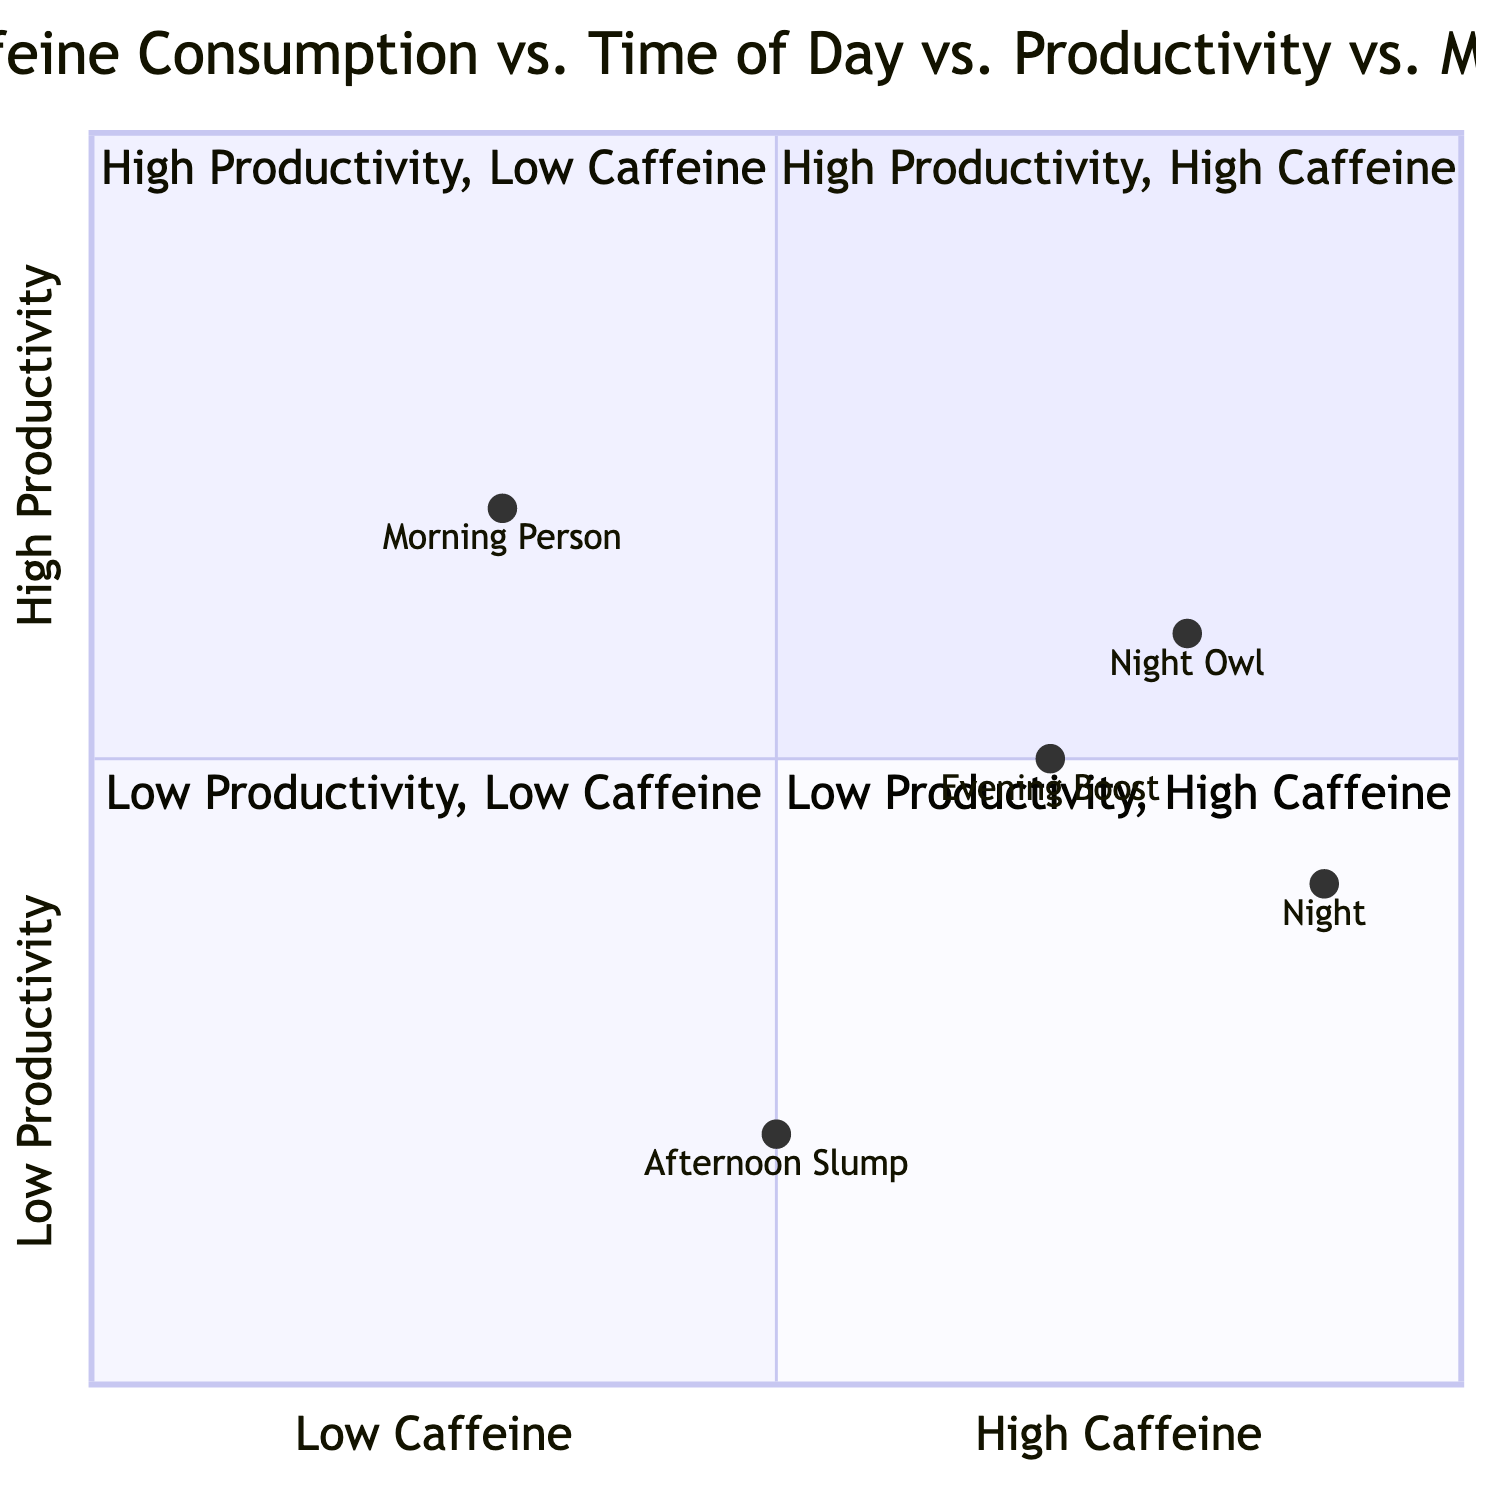What is the quadrant with high productivity and high caffeine? In the quadrant chart, quadrant 1 represents high productivity and high caffeine levels.
Answer: Quadrant 1 How many periods of time are represented in the chart? The chart describes four periods of time: morning, afternoon, evening, and night.
Answer: Four Which period corresponds to the night owl's metrics? The night owl's metrics are indicated by the coordinates [0.8, 0.6], which fall within the night period on the chart.
Answer: Night Is the productivity level of the morning person high or low? The morning person's metrics are shown as [0.3, 0.7], indicating a high productivity level since it is positioned towards the high side of the y-axis.
Answer: High In which quadrant would the "Afternoon Slump" fall? The "Afternoon Slump" is represented by the coordinates [0.5, 0.2], which places it in quadrant 3, characterized by low productivity and low caffeine.
Answer: Quadrant 3 What mood level does a night owl have according to the chart? The night owl falls in the quadrant where caffeine is high, and their productivity is moderate, reflecting a mood level that can be classified as high.
Answer: High Which quadrant has low caffeine and high productivity? Quadrant 2 in the chart is defined by high productivity and low caffeine consumption.
Answer: Quadrant 2 What is the caffeine consumption level for the evening boost? The evening boost is indicated by the coordinates [0.7, 0.5], positioning it in a high caffeine level.
Answer: High What does the coordinate [0.9, 0.4] represent? This coordinate corresponds to the night period, indicating high caffeine consumption and moderate productivity levels based on the quadrant analysis.
Answer: Night Which quadrant contains individuals with low productivity levels? Quadrants 3 and 4 both feature low productivity levels, with quadrant 3 being characterized by low caffeine and quadrant 4 by high caffeine.
Answer: Quadrants 3 and 4 